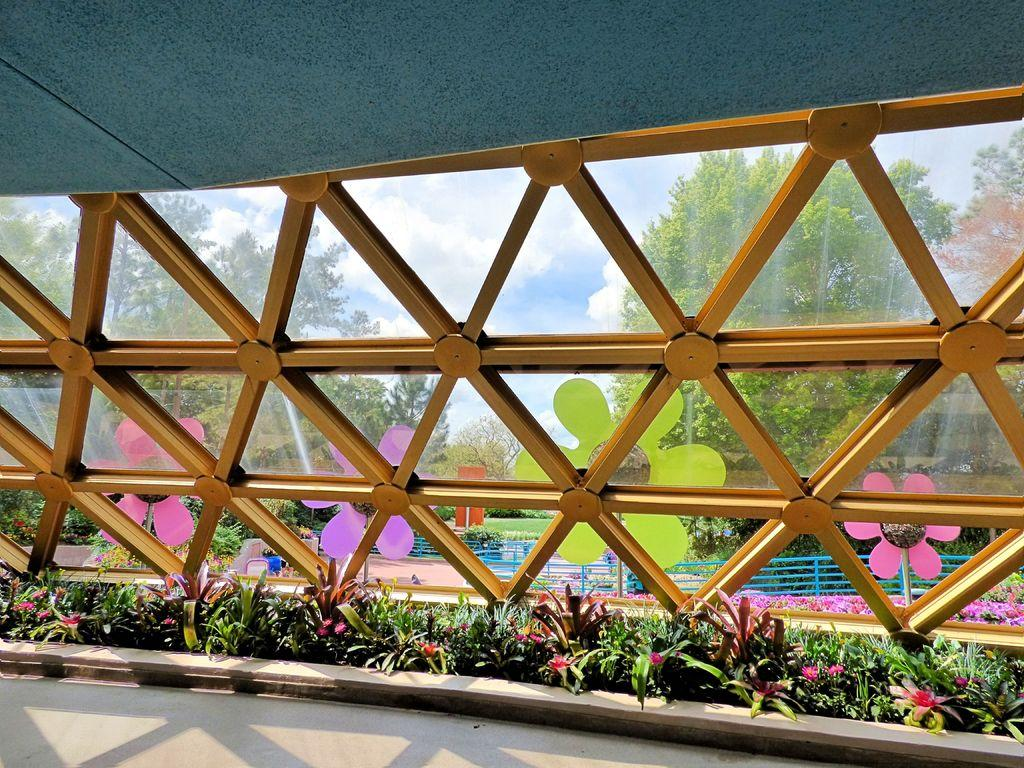What type of plants can be seen in the image? There are green color plants in the image. Can you describe any other objects in the image? There is a yellow color glass frame in the image. What can be seen in the background of the image? There are green color plants and the sky visible in the background of the image. What type of spring can be seen in the image? There is no spring present in the image; it features green color plants and a yellow color glass frame. 